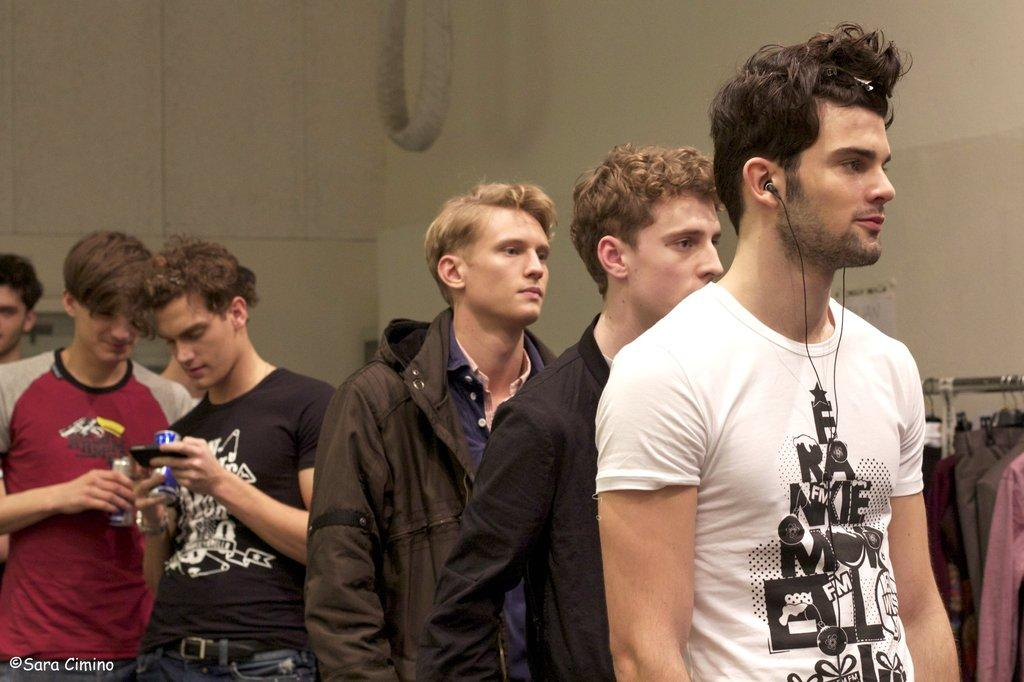How many people are present in the image? There are six persons in the image. Can you describe the man standing in the front? The man standing in the front is wearing a white T-shirt. What can be seen on the right side of the image? There are clothes hanged on a rod on the right side. What is visible in the background of the image? There is a wall in the background of the image. What is the daughter of the man wearing a white T-shirt doing in the image? There is no mention of a daughter in the image, so it is not possible to answer that question. 